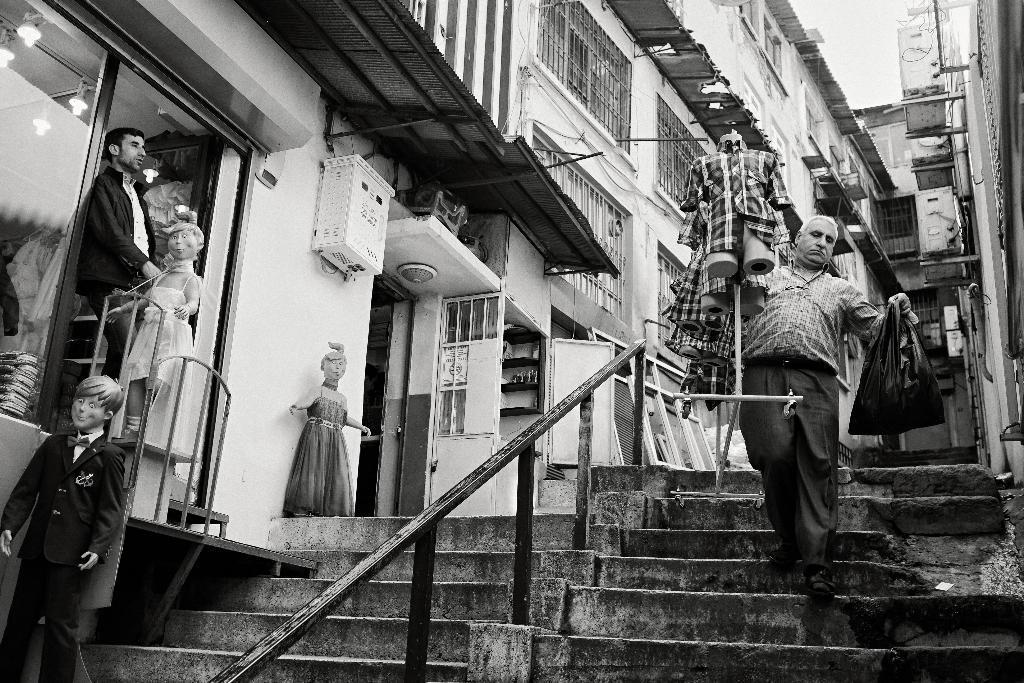Describe this image in one or two sentences. In this picture we can see stairs at the bottom, on the left side we can see mannequins, there are buildings in the background, we can see grills here, on the left side there is glass, we can see a person here. 